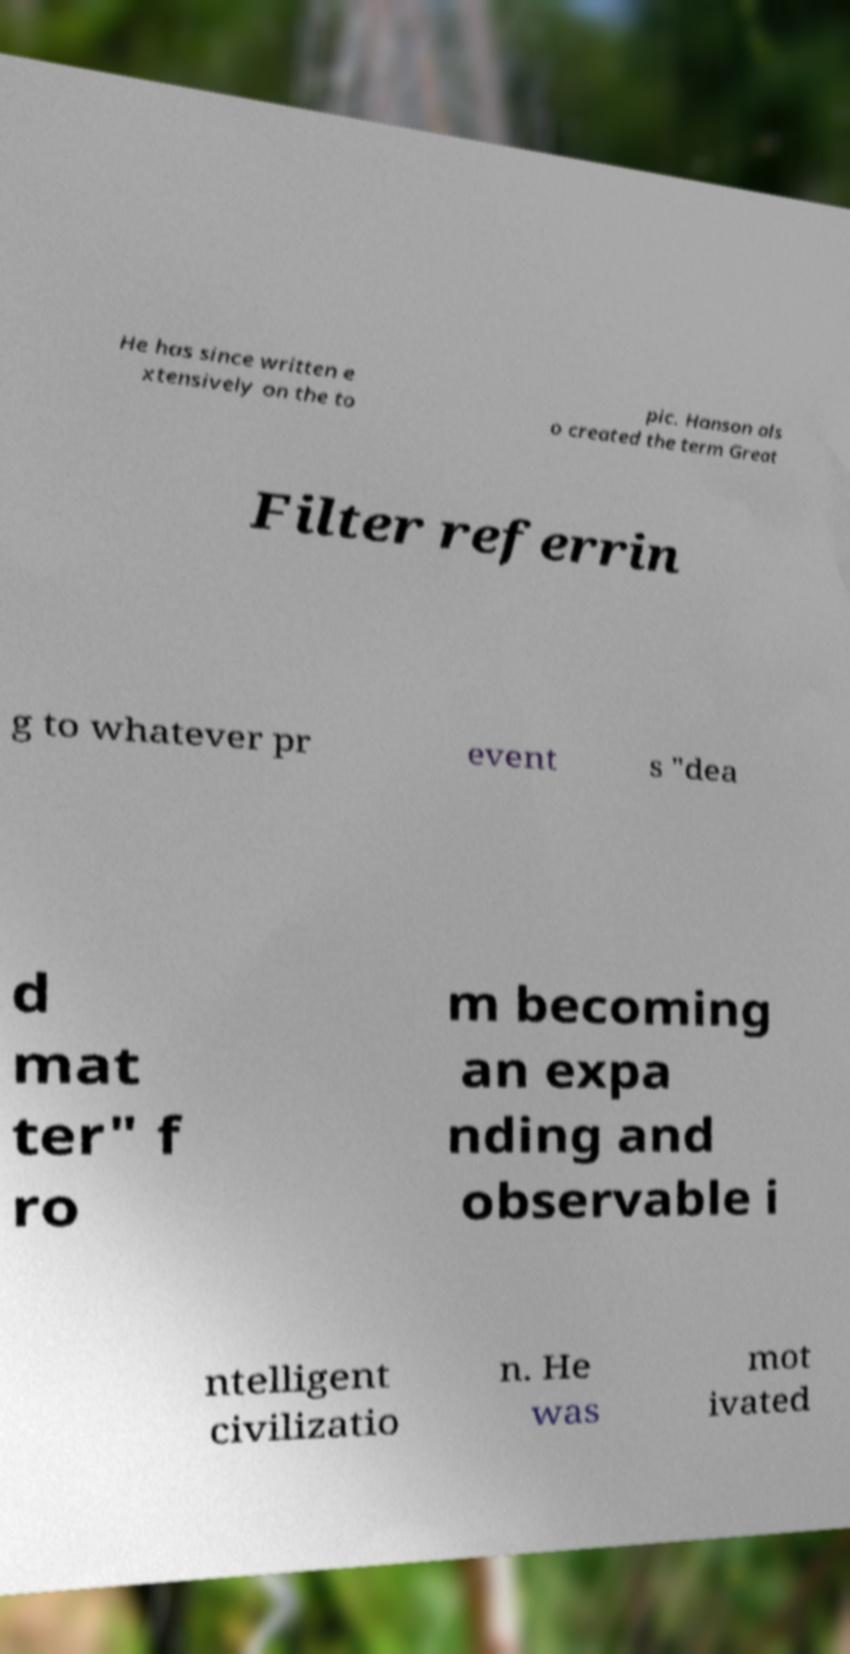Please read and relay the text visible in this image. What does it say? He has since written e xtensively on the to pic. Hanson als o created the term Great Filter referrin g to whatever pr event s "dea d mat ter" f ro m becoming an expa nding and observable i ntelligent civilizatio n. He was mot ivated 